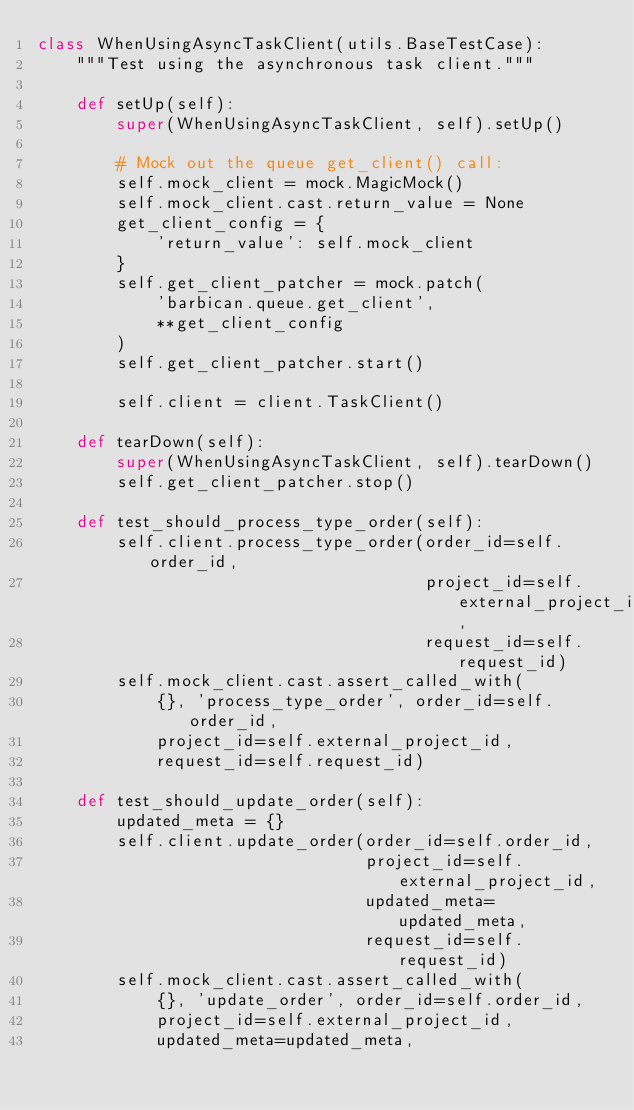<code> <loc_0><loc_0><loc_500><loc_500><_Python_>class WhenUsingAsyncTaskClient(utils.BaseTestCase):
    """Test using the asynchronous task client."""

    def setUp(self):
        super(WhenUsingAsyncTaskClient, self).setUp()

        # Mock out the queue get_client() call:
        self.mock_client = mock.MagicMock()
        self.mock_client.cast.return_value = None
        get_client_config = {
            'return_value': self.mock_client
        }
        self.get_client_patcher = mock.patch(
            'barbican.queue.get_client',
            **get_client_config
        )
        self.get_client_patcher.start()

        self.client = client.TaskClient()

    def tearDown(self):
        super(WhenUsingAsyncTaskClient, self).tearDown()
        self.get_client_patcher.stop()

    def test_should_process_type_order(self):
        self.client.process_type_order(order_id=self.order_id,
                                       project_id=self.external_project_id,
                                       request_id=self.request_id)
        self.mock_client.cast.assert_called_with(
            {}, 'process_type_order', order_id=self.order_id,
            project_id=self.external_project_id,
            request_id=self.request_id)

    def test_should_update_order(self):
        updated_meta = {}
        self.client.update_order(order_id=self.order_id,
                                 project_id=self.external_project_id,
                                 updated_meta=updated_meta,
                                 request_id=self.request_id)
        self.mock_client.cast.assert_called_with(
            {}, 'update_order', order_id=self.order_id,
            project_id=self.external_project_id,
            updated_meta=updated_meta,</code> 